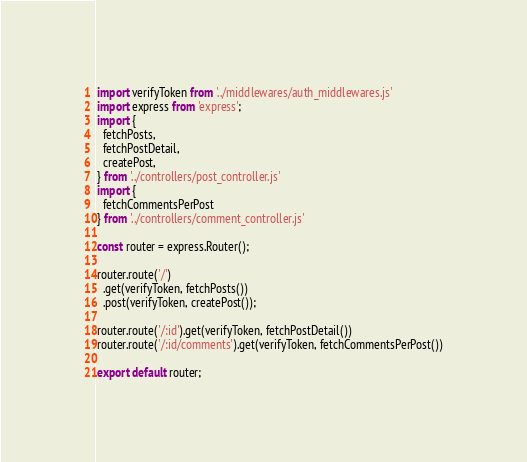Convert code to text. <code><loc_0><loc_0><loc_500><loc_500><_JavaScript_>import verifyToken from '../middlewares/auth_middlewares.js'
import express from 'express';
import {
  fetchPosts,
  fetchPostDetail,
  createPost,
} from '../controllers/post_controller.js'
import {
  fetchCommentsPerPost
} from '../controllers/comment_controller.js'

const router = express.Router();

router.route('/')
  .get(verifyToken, fetchPosts())
  .post(verifyToken, createPost());

router.route('/:id').get(verifyToken, fetchPostDetail())
router.route('/:id/comments').get(verifyToken, fetchCommentsPerPost())

export default router;
</code> 